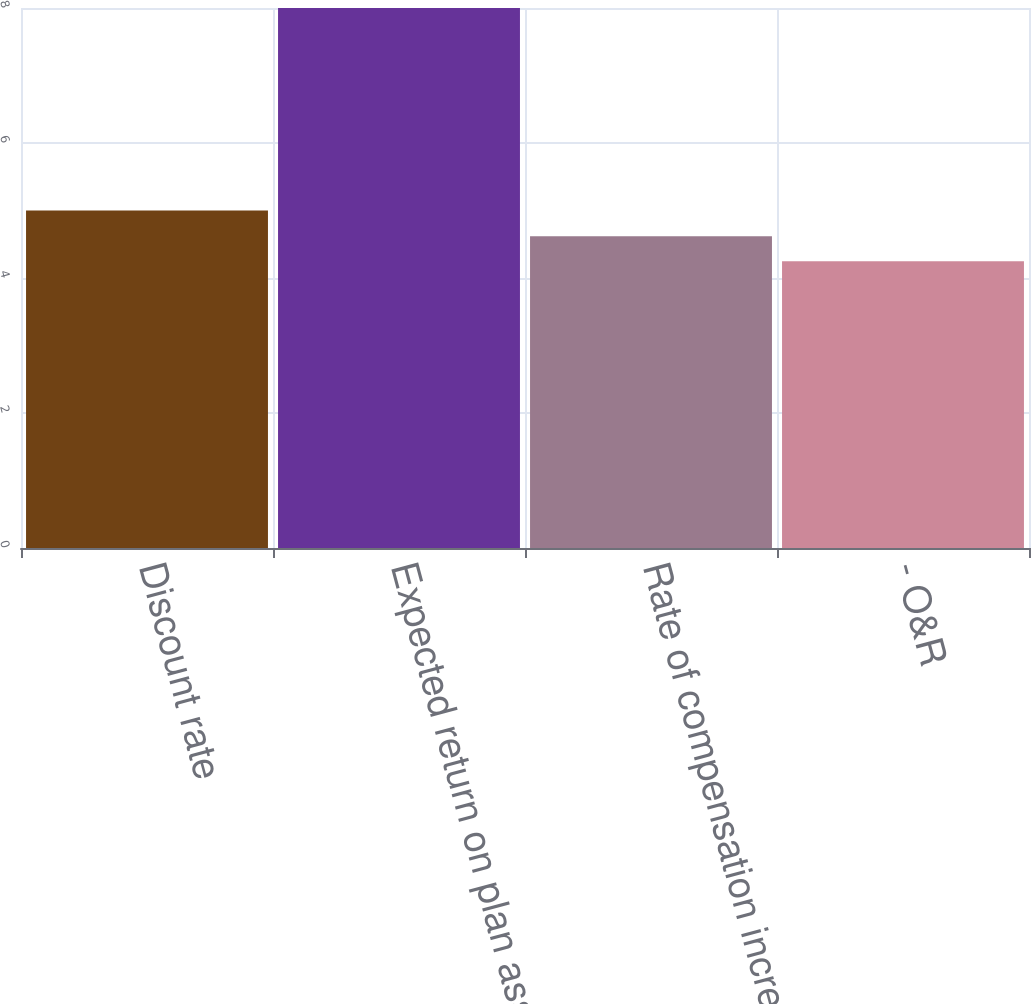Convert chart to OTSL. <chart><loc_0><loc_0><loc_500><loc_500><bar_chart><fcel>Discount rate<fcel>Expected return on plan assets<fcel>Rate of compensation increase<fcel>- O&R<nl><fcel>5<fcel>8<fcel>4.62<fcel>4.25<nl></chart> 